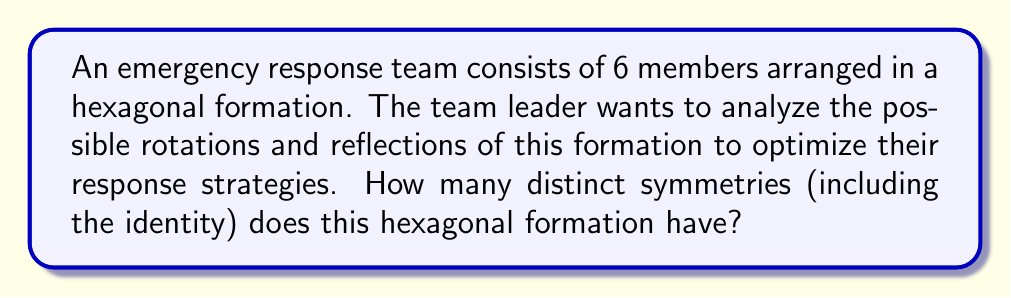Solve this math problem. To solve this problem, we need to consider the symmetry group of a regular hexagon, which is the dihedral group $D_6$.

1) First, let's count the rotational symmetries:
   - The hexagon can be rotated by 0°, 60°, 120°, 180°, 240°, and 300°.
   - This gives us 6 rotational symmetries (including the identity rotation of 0°).

2) Now, let's count the reflection symmetries:
   - A hexagon has 6 lines of reflection: 3 passing through opposite vertices and 3 passing through the midpoints of opposite sides.

3) The total number of symmetries is the sum of rotational and reflection symmetries:
   $$ \text{Total symmetries} = \text{Rotational symmetries} + \text{Reflection symmetries} $$
   $$ \text{Total symmetries} = 6 + 6 = 12 $$

4) We can also express this in terms of the order of the dihedral group $D_6$:
   $$ |D_6| = 2n = 2(6) = 12 $$
   where $n$ is the number of sides in the polygon (in this case, 6 for a hexagon).

This means that there are 12 distinct ways the hexagonal formation can be transformed while maintaining its overall shape and structure. Each of these symmetries represents a potential configuration that the emergency response team could adopt, allowing them to quickly reorganize while maintaining their formation integrity.
Answer: The hexagonal formation of the emergency response team has 12 distinct symmetries. 